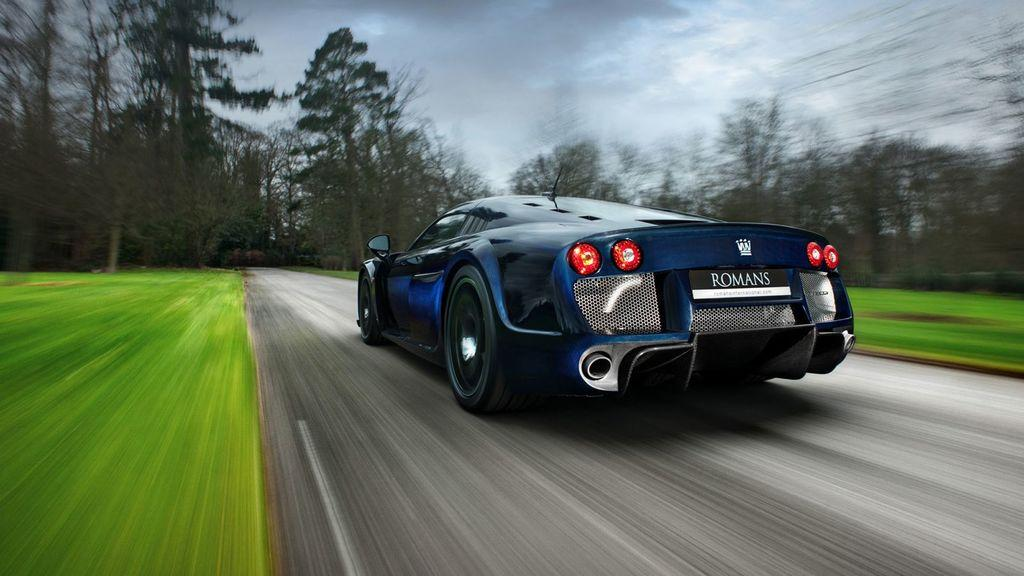What is the main subject of the image? There is a car in the image. Where is the car located? The car is on the road. Is the car moving or stationary in the image? The car is in motion in the image. What can be seen in the surroundings of the car? There are many trees around the car. What type of answer can be seen being given by the car in the image? There is no indication in the image that the car is giving any answers, as cars do not have the ability to communicate in that manner. 